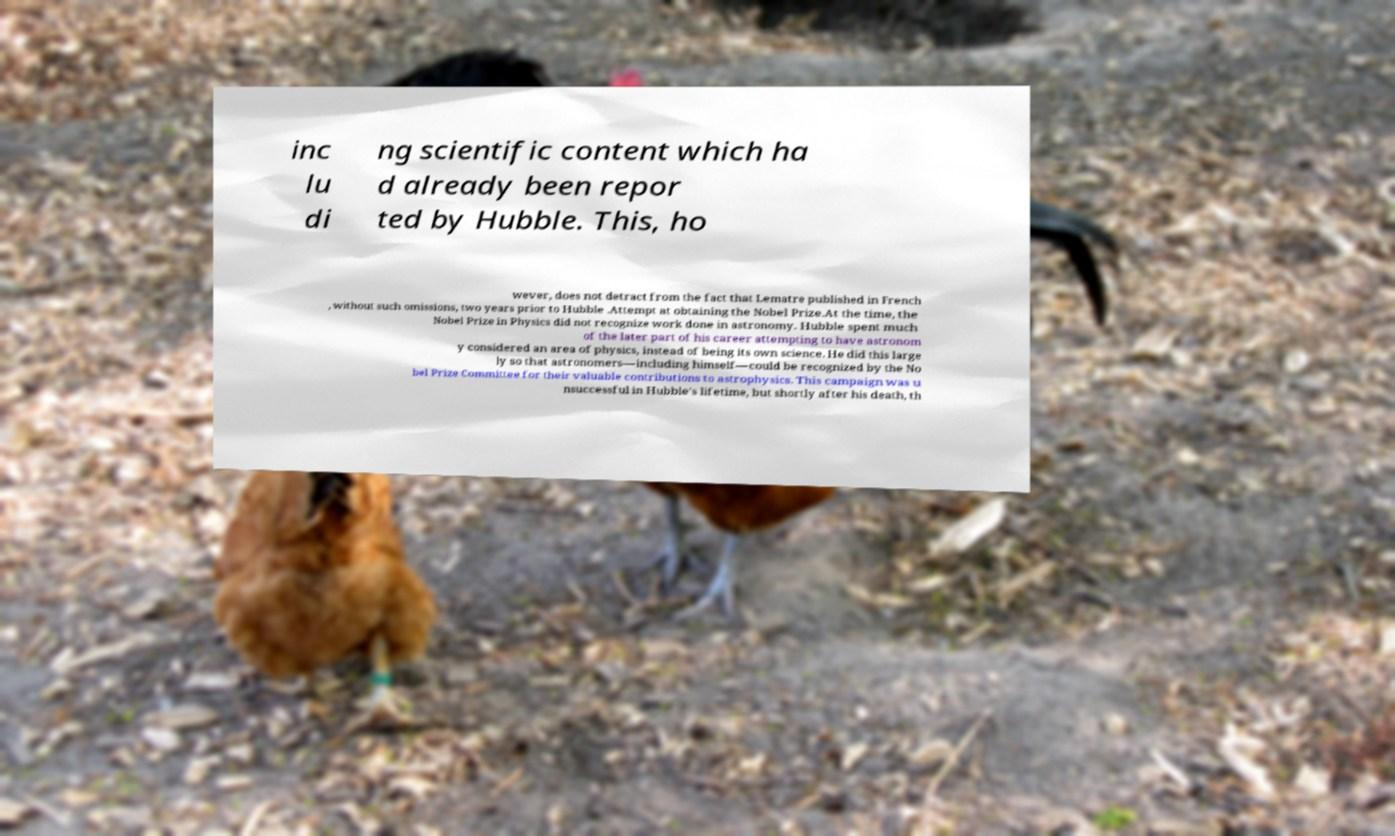Could you extract and type out the text from this image? inc lu di ng scientific content which ha d already been repor ted by Hubble. This, ho wever, does not detract from the fact that Lematre published in French , without such omissions, two years prior to Hubble .Attempt at obtaining the Nobel Prize.At the time, the Nobel Prize in Physics did not recognize work done in astronomy. Hubble spent much of the later part of his career attempting to have astronom y considered an area of physics, instead of being its own science. He did this large ly so that astronomers—including himself—could be recognized by the No bel Prize Committee for their valuable contributions to astrophysics. This campaign was u nsuccessful in Hubble's lifetime, but shortly after his death, th 